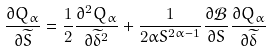Convert formula to latex. <formula><loc_0><loc_0><loc_500><loc_500>\frac { \partial Q _ { \alpha } } { \partial \widetilde { S } } = \frac { 1 } { 2 } \frac { \partial ^ { 2 } Q _ { \alpha } } { \partial \widetilde { \delta } ^ { 2 } } + \frac { 1 } { 2 \alpha S ^ { 2 \alpha - 1 } } \frac { \partial { \mathcal { B } } } { \partial S } \frac { \partial Q _ { \alpha } } { \partial \widetilde { \delta } }</formula> 